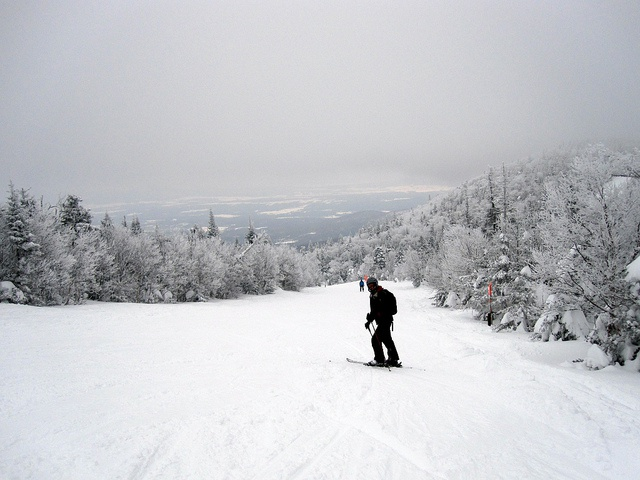Describe the objects in this image and their specific colors. I can see people in darkgray, black, gray, and lightgray tones, backpack in darkgray, black, gray, and white tones, skis in darkgray, lightgray, and gray tones, and people in darkgray, black, navy, gray, and blue tones in this image. 